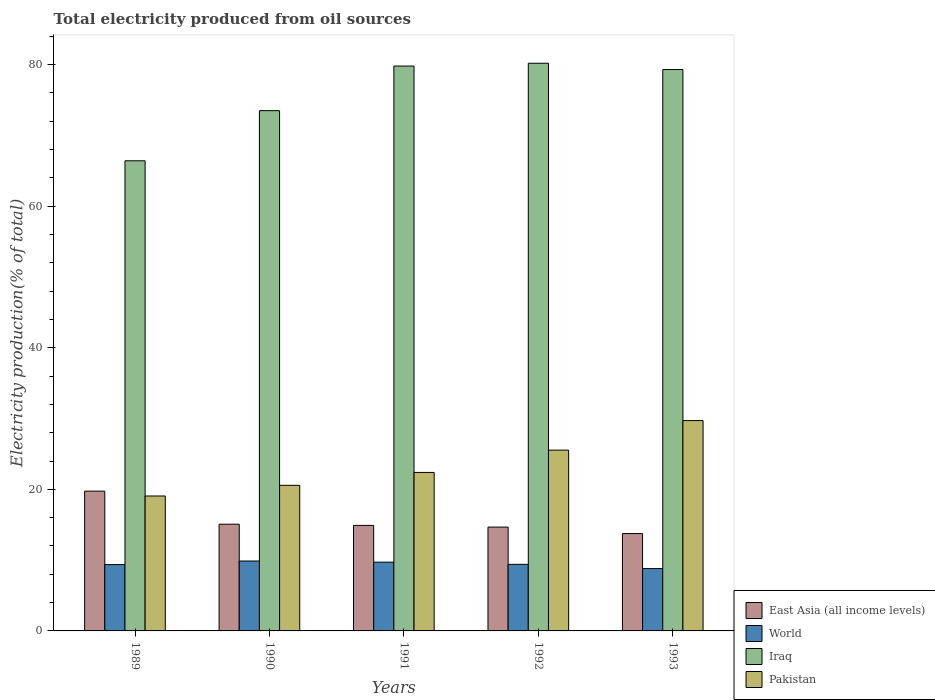Are the number of bars on each tick of the X-axis equal?
Provide a short and direct response. Yes. How many bars are there on the 3rd tick from the left?
Make the answer very short. 4. What is the label of the 5th group of bars from the left?
Provide a succinct answer. 1993. What is the total electricity produced in East Asia (all income levels) in 1992?
Provide a short and direct response. 14.67. Across all years, what is the maximum total electricity produced in Pakistan?
Ensure brevity in your answer.  29.71. Across all years, what is the minimum total electricity produced in Iraq?
Give a very brief answer. 66.41. What is the total total electricity produced in Iraq in the graph?
Make the answer very short. 379.17. What is the difference between the total electricity produced in World in 1990 and that in 1992?
Give a very brief answer. 0.47. What is the difference between the total electricity produced in East Asia (all income levels) in 1993 and the total electricity produced in World in 1990?
Your answer should be very brief. 3.88. What is the average total electricity produced in Iraq per year?
Your answer should be very brief. 75.83. In the year 1990, what is the difference between the total electricity produced in World and total electricity produced in Pakistan?
Make the answer very short. -10.69. In how many years, is the total electricity produced in Iraq greater than 60 %?
Your response must be concise. 5. What is the ratio of the total electricity produced in World in 1992 to that in 1993?
Ensure brevity in your answer.  1.07. Is the difference between the total electricity produced in World in 1989 and 1993 greater than the difference between the total electricity produced in Pakistan in 1989 and 1993?
Your answer should be very brief. Yes. What is the difference between the highest and the second highest total electricity produced in Iraq?
Keep it short and to the point. 0.4. What is the difference between the highest and the lowest total electricity produced in World?
Provide a succinct answer. 1.07. Is it the case that in every year, the sum of the total electricity produced in Pakistan and total electricity produced in World is greater than the sum of total electricity produced in East Asia (all income levels) and total electricity produced in Iraq?
Offer a terse response. No. What does the 4th bar from the right in 1991 represents?
Provide a short and direct response. East Asia (all income levels). Is it the case that in every year, the sum of the total electricity produced in Pakistan and total electricity produced in Iraq is greater than the total electricity produced in World?
Provide a succinct answer. Yes. How many years are there in the graph?
Your answer should be compact. 5. What is the difference between two consecutive major ticks on the Y-axis?
Offer a terse response. 20. Are the values on the major ticks of Y-axis written in scientific E-notation?
Make the answer very short. No. Does the graph contain grids?
Provide a succinct answer. No. Where does the legend appear in the graph?
Make the answer very short. Bottom right. How many legend labels are there?
Ensure brevity in your answer.  4. How are the legend labels stacked?
Your response must be concise. Vertical. What is the title of the graph?
Provide a short and direct response. Total electricity produced from oil sources. What is the label or title of the X-axis?
Offer a very short reply. Years. What is the label or title of the Y-axis?
Give a very brief answer. Electricity production(% of total). What is the Electricity production(% of total) in East Asia (all income levels) in 1989?
Give a very brief answer. 19.75. What is the Electricity production(% of total) in World in 1989?
Give a very brief answer. 9.37. What is the Electricity production(% of total) in Iraq in 1989?
Provide a short and direct response. 66.41. What is the Electricity production(% of total) of Pakistan in 1989?
Offer a very short reply. 19.06. What is the Electricity production(% of total) in East Asia (all income levels) in 1990?
Your answer should be very brief. 15.08. What is the Electricity production(% of total) of World in 1990?
Your answer should be very brief. 9.88. What is the Electricity production(% of total) in Iraq in 1990?
Your response must be concise. 73.49. What is the Electricity production(% of total) of Pakistan in 1990?
Offer a terse response. 20.57. What is the Electricity production(% of total) of East Asia (all income levels) in 1991?
Make the answer very short. 14.91. What is the Electricity production(% of total) of World in 1991?
Offer a very short reply. 9.72. What is the Electricity production(% of total) of Iraq in 1991?
Provide a short and direct response. 79.79. What is the Electricity production(% of total) in Pakistan in 1991?
Give a very brief answer. 22.39. What is the Electricity production(% of total) of East Asia (all income levels) in 1992?
Your answer should be compact. 14.67. What is the Electricity production(% of total) of World in 1992?
Your response must be concise. 9.4. What is the Electricity production(% of total) in Iraq in 1992?
Give a very brief answer. 80.19. What is the Electricity production(% of total) of Pakistan in 1992?
Provide a short and direct response. 25.54. What is the Electricity production(% of total) of East Asia (all income levels) in 1993?
Ensure brevity in your answer.  13.75. What is the Electricity production(% of total) of World in 1993?
Ensure brevity in your answer.  8.8. What is the Electricity production(% of total) in Iraq in 1993?
Offer a terse response. 79.3. What is the Electricity production(% of total) of Pakistan in 1993?
Offer a terse response. 29.71. Across all years, what is the maximum Electricity production(% of total) of East Asia (all income levels)?
Keep it short and to the point. 19.75. Across all years, what is the maximum Electricity production(% of total) in World?
Make the answer very short. 9.88. Across all years, what is the maximum Electricity production(% of total) of Iraq?
Keep it short and to the point. 80.19. Across all years, what is the maximum Electricity production(% of total) of Pakistan?
Provide a succinct answer. 29.71. Across all years, what is the minimum Electricity production(% of total) in East Asia (all income levels)?
Your answer should be very brief. 13.75. Across all years, what is the minimum Electricity production(% of total) in World?
Make the answer very short. 8.8. Across all years, what is the minimum Electricity production(% of total) in Iraq?
Offer a very short reply. 66.41. Across all years, what is the minimum Electricity production(% of total) in Pakistan?
Keep it short and to the point. 19.06. What is the total Electricity production(% of total) in East Asia (all income levels) in the graph?
Offer a very short reply. 78.15. What is the total Electricity production(% of total) in World in the graph?
Offer a very short reply. 47.17. What is the total Electricity production(% of total) in Iraq in the graph?
Keep it short and to the point. 379.17. What is the total Electricity production(% of total) in Pakistan in the graph?
Offer a terse response. 117.26. What is the difference between the Electricity production(% of total) in East Asia (all income levels) in 1989 and that in 1990?
Your answer should be compact. 4.67. What is the difference between the Electricity production(% of total) of World in 1989 and that in 1990?
Provide a short and direct response. -0.51. What is the difference between the Electricity production(% of total) in Iraq in 1989 and that in 1990?
Ensure brevity in your answer.  -7.08. What is the difference between the Electricity production(% of total) in Pakistan in 1989 and that in 1990?
Offer a very short reply. -1.51. What is the difference between the Electricity production(% of total) in East Asia (all income levels) in 1989 and that in 1991?
Offer a very short reply. 4.84. What is the difference between the Electricity production(% of total) in World in 1989 and that in 1991?
Keep it short and to the point. -0.35. What is the difference between the Electricity production(% of total) in Iraq in 1989 and that in 1991?
Offer a very short reply. -13.38. What is the difference between the Electricity production(% of total) of Pakistan in 1989 and that in 1991?
Provide a short and direct response. -3.33. What is the difference between the Electricity production(% of total) in East Asia (all income levels) in 1989 and that in 1992?
Keep it short and to the point. 5.08. What is the difference between the Electricity production(% of total) in World in 1989 and that in 1992?
Your answer should be compact. -0.04. What is the difference between the Electricity production(% of total) of Iraq in 1989 and that in 1992?
Provide a short and direct response. -13.78. What is the difference between the Electricity production(% of total) in Pakistan in 1989 and that in 1992?
Make the answer very short. -6.48. What is the difference between the Electricity production(% of total) of East Asia (all income levels) in 1989 and that in 1993?
Ensure brevity in your answer.  5.99. What is the difference between the Electricity production(% of total) in World in 1989 and that in 1993?
Make the answer very short. 0.56. What is the difference between the Electricity production(% of total) of Iraq in 1989 and that in 1993?
Your response must be concise. -12.89. What is the difference between the Electricity production(% of total) of Pakistan in 1989 and that in 1993?
Your answer should be very brief. -10.65. What is the difference between the Electricity production(% of total) in East Asia (all income levels) in 1990 and that in 1991?
Your answer should be very brief. 0.17. What is the difference between the Electricity production(% of total) of World in 1990 and that in 1991?
Provide a succinct answer. 0.16. What is the difference between the Electricity production(% of total) in Iraq in 1990 and that in 1991?
Your answer should be very brief. -6.3. What is the difference between the Electricity production(% of total) in Pakistan in 1990 and that in 1991?
Provide a succinct answer. -1.82. What is the difference between the Electricity production(% of total) in East Asia (all income levels) in 1990 and that in 1992?
Offer a terse response. 0.41. What is the difference between the Electricity production(% of total) of World in 1990 and that in 1992?
Give a very brief answer. 0.47. What is the difference between the Electricity production(% of total) in Iraq in 1990 and that in 1992?
Make the answer very short. -6.69. What is the difference between the Electricity production(% of total) in Pakistan in 1990 and that in 1992?
Provide a short and direct response. -4.97. What is the difference between the Electricity production(% of total) in East Asia (all income levels) in 1990 and that in 1993?
Ensure brevity in your answer.  1.32. What is the difference between the Electricity production(% of total) in World in 1990 and that in 1993?
Ensure brevity in your answer.  1.07. What is the difference between the Electricity production(% of total) of Iraq in 1990 and that in 1993?
Your answer should be very brief. -5.8. What is the difference between the Electricity production(% of total) of Pakistan in 1990 and that in 1993?
Offer a very short reply. -9.14. What is the difference between the Electricity production(% of total) in East Asia (all income levels) in 1991 and that in 1992?
Offer a very short reply. 0.24. What is the difference between the Electricity production(% of total) in World in 1991 and that in 1992?
Make the answer very short. 0.31. What is the difference between the Electricity production(% of total) in Iraq in 1991 and that in 1992?
Keep it short and to the point. -0.4. What is the difference between the Electricity production(% of total) in Pakistan in 1991 and that in 1992?
Your response must be concise. -3.15. What is the difference between the Electricity production(% of total) in East Asia (all income levels) in 1991 and that in 1993?
Keep it short and to the point. 1.15. What is the difference between the Electricity production(% of total) in World in 1991 and that in 1993?
Offer a terse response. 0.91. What is the difference between the Electricity production(% of total) of Iraq in 1991 and that in 1993?
Make the answer very short. 0.49. What is the difference between the Electricity production(% of total) of Pakistan in 1991 and that in 1993?
Your response must be concise. -7.32. What is the difference between the Electricity production(% of total) in East Asia (all income levels) in 1992 and that in 1993?
Make the answer very short. 0.92. What is the difference between the Electricity production(% of total) of World in 1992 and that in 1993?
Offer a terse response. 0.6. What is the difference between the Electricity production(% of total) of Iraq in 1992 and that in 1993?
Your response must be concise. 0.89. What is the difference between the Electricity production(% of total) in Pakistan in 1992 and that in 1993?
Your response must be concise. -4.17. What is the difference between the Electricity production(% of total) in East Asia (all income levels) in 1989 and the Electricity production(% of total) in World in 1990?
Keep it short and to the point. 9.87. What is the difference between the Electricity production(% of total) of East Asia (all income levels) in 1989 and the Electricity production(% of total) of Iraq in 1990?
Make the answer very short. -53.75. What is the difference between the Electricity production(% of total) of East Asia (all income levels) in 1989 and the Electricity production(% of total) of Pakistan in 1990?
Make the answer very short. -0.82. What is the difference between the Electricity production(% of total) in World in 1989 and the Electricity production(% of total) in Iraq in 1990?
Ensure brevity in your answer.  -64.12. What is the difference between the Electricity production(% of total) in World in 1989 and the Electricity production(% of total) in Pakistan in 1990?
Keep it short and to the point. -11.2. What is the difference between the Electricity production(% of total) of Iraq in 1989 and the Electricity production(% of total) of Pakistan in 1990?
Keep it short and to the point. 45.84. What is the difference between the Electricity production(% of total) in East Asia (all income levels) in 1989 and the Electricity production(% of total) in World in 1991?
Your response must be concise. 10.03. What is the difference between the Electricity production(% of total) in East Asia (all income levels) in 1989 and the Electricity production(% of total) in Iraq in 1991?
Your answer should be very brief. -60.04. What is the difference between the Electricity production(% of total) of East Asia (all income levels) in 1989 and the Electricity production(% of total) of Pakistan in 1991?
Your response must be concise. -2.64. What is the difference between the Electricity production(% of total) in World in 1989 and the Electricity production(% of total) in Iraq in 1991?
Ensure brevity in your answer.  -70.42. What is the difference between the Electricity production(% of total) in World in 1989 and the Electricity production(% of total) in Pakistan in 1991?
Keep it short and to the point. -13.02. What is the difference between the Electricity production(% of total) in Iraq in 1989 and the Electricity production(% of total) in Pakistan in 1991?
Your answer should be compact. 44.02. What is the difference between the Electricity production(% of total) in East Asia (all income levels) in 1989 and the Electricity production(% of total) in World in 1992?
Your response must be concise. 10.34. What is the difference between the Electricity production(% of total) in East Asia (all income levels) in 1989 and the Electricity production(% of total) in Iraq in 1992?
Offer a terse response. -60.44. What is the difference between the Electricity production(% of total) of East Asia (all income levels) in 1989 and the Electricity production(% of total) of Pakistan in 1992?
Ensure brevity in your answer.  -5.79. What is the difference between the Electricity production(% of total) in World in 1989 and the Electricity production(% of total) in Iraq in 1992?
Your answer should be very brief. -70.82. What is the difference between the Electricity production(% of total) of World in 1989 and the Electricity production(% of total) of Pakistan in 1992?
Keep it short and to the point. -16.17. What is the difference between the Electricity production(% of total) in Iraq in 1989 and the Electricity production(% of total) in Pakistan in 1992?
Give a very brief answer. 40.87. What is the difference between the Electricity production(% of total) in East Asia (all income levels) in 1989 and the Electricity production(% of total) in World in 1993?
Keep it short and to the point. 10.94. What is the difference between the Electricity production(% of total) in East Asia (all income levels) in 1989 and the Electricity production(% of total) in Iraq in 1993?
Provide a succinct answer. -59.55. What is the difference between the Electricity production(% of total) in East Asia (all income levels) in 1989 and the Electricity production(% of total) in Pakistan in 1993?
Give a very brief answer. -9.96. What is the difference between the Electricity production(% of total) in World in 1989 and the Electricity production(% of total) in Iraq in 1993?
Your answer should be very brief. -69.93. What is the difference between the Electricity production(% of total) in World in 1989 and the Electricity production(% of total) in Pakistan in 1993?
Keep it short and to the point. -20.34. What is the difference between the Electricity production(% of total) of Iraq in 1989 and the Electricity production(% of total) of Pakistan in 1993?
Make the answer very short. 36.7. What is the difference between the Electricity production(% of total) of East Asia (all income levels) in 1990 and the Electricity production(% of total) of World in 1991?
Ensure brevity in your answer.  5.36. What is the difference between the Electricity production(% of total) of East Asia (all income levels) in 1990 and the Electricity production(% of total) of Iraq in 1991?
Give a very brief answer. -64.71. What is the difference between the Electricity production(% of total) in East Asia (all income levels) in 1990 and the Electricity production(% of total) in Pakistan in 1991?
Your response must be concise. -7.31. What is the difference between the Electricity production(% of total) of World in 1990 and the Electricity production(% of total) of Iraq in 1991?
Offer a terse response. -69.91. What is the difference between the Electricity production(% of total) of World in 1990 and the Electricity production(% of total) of Pakistan in 1991?
Your answer should be compact. -12.51. What is the difference between the Electricity production(% of total) of Iraq in 1990 and the Electricity production(% of total) of Pakistan in 1991?
Give a very brief answer. 51.1. What is the difference between the Electricity production(% of total) of East Asia (all income levels) in 1990 and the Electricity production(% of total) of World in 1992?
Provide a short and direct response. 5.67. What is the difference between the Electricity production(% of total) in East Asia (all income levels) in 1990 and the Electricity production(% of total) in Iraq in 1992?
Keep it short and to the point. -65.11. What is the difference between the Electricity production(% of total) in East Asia (all income levels) in 1990 and the Electricity production(% of total) in Pakistan in 1992?
Provide a succinct answer. -10.46. What is the difference between the Electricity production(% of total) in World in 1990 and the Electricity production(% of total) in Iraq in 1992?
Your answer should be very brief. -70.31. What is the difference between the Electricity production(% of total) of World in 1990 and the Electricity production(% of total) of Pakistan in 1992?
Give a very brief answer. -15.66. What is the difference between the Electricity production(% of total) of Iraq in 1990 and the Electricity production(% of total) of Pakistan in 1992?
Give a very brief answer. 47.95. What is the difference between the Electricity production(% of total) in East Asia (all income levels) in 1990 and the Electricity production(% of total) in World in 1993?
Your answer should be compact. 6.27. What is the difference between the Electricity production(% of total) of East Asia (all income levels) in 1990 and the Electricity production(% of total) of Iraq in 1993?
Keep it short and to the point. -64.22. What is the difference between the Electricity production(% of total) in East Asia (all income levels) in 1990 and the Electricity production(% of total) in Pakistan in 1993?
Make the answer very short. -14.63. What is the difference between the Electricity production(% of total) in World in 1990 and the Electricity production(% of total) in Iraq in 1993?
Make the answer very short. -69.42. What is the difference between the Electricity production(% of total) in World in 1990 and the Electricity production(% of total) in Pakistan in 1993?
Provide a succinct answer. -19.83. What is the difference between the Electricity production(% of total) of Iraq in 1990 and the Electricity production(% of total) of Pakistan in 1993?
Give a very brief answer. 43.78. What is the difference between the Electricity production(% of total) of East Asia (all income levels) in 1991 and the Electricity production(% of total) of World in 1992?
Give a very brief answer. 5.5. What is the difference between the Electricity production(% of total) of East Asia (all income levels) in 1991 and the Electricity production(% of total) of Iraq in 1992?
Provide a succinct answer. -65.28. What is the difference between the Electricity production(% of total) of East Asia (all income levels) in 1991 and the Electricity production(% of total) of Pakistan in 1992?
Make the answer very short. -10.63. What is the difference between the Electricity production(% of total) in World in 1991 and the Electricity production(% of total) in Iraq in 1992?
Give a very brief answer. -70.47. What is the difference between the Electricity production(% of total) of World in 1991 and the Electricity production(% of total) of Pakistan in 1992?
Give a very brief answer. -15.82. What is the difference between the Electricity production(% of total) of Iraq in 1991 and the Electricity production(% of total) of Pakistan in 1992?
Keep it short and to the point. 54.25. What is the difference between the Electricity production(% of total) in East Asia (all income levels) in 1991 and the Electricity production(% of total) in World in 1993?
Make the answer very short. 6.1. What is the difference between the Electricity production(% of total) of East Asia (all income levels) in 1991 and the Electricity production(% of total) of Iraq in 1993?
Give a very brief answer. -64.39. What is the difference between the Electricity production(% of total) in East Asia (all income levels) in 1991 and the Electricity production(% of total) in Pakistan in 1993?
Offer a terse response. -14.8. What is the difference between the Electricity production(% of total) in World in 1991 and the Electricity production(% of total) in Iraq in 1993?
Provide a succinct answer. -69.58. What is the difference between the Electricity production(% of total) of World in 1991 and the Electricity production(% of total) of Pakistan in 1993?
Your answer should be compact. -20. What is the difference between the Electricity production(% of total) in Iraq in 1991 and the Electricity production(% of total) in Pakistan in 1993?
Your response must be concise. 50.08. What is the difference between the Electricity production(% of total) in East Asia (all income levels) in 1992 and the Electricity production(% of total) in World in 1993?
Provide a succinct answer. 5.86. What is the difference between the Electricity production(% of total) of East Asia (all income levels) in 1992 and the Electricity production(% of total) of Iraq in 1993?
Offer a very short reply. -64.63. What is the difference between the Electricity production(% of total) in East Asia (all income levels) in 1992 and the Electricity production(% of total) in Pakistan in 1993?
Ensure brevity in your answer.  -15.04. What is the difference between the Electricity production(% of total) in World in 1992 and the Electricity production(% of total) in Iraq in 1993?
Your answer should be very brief. -69.89. What is the difference between the Electricity production(% of total) of World in 1992 and the Electricity production(% of total) of Pakistan in 1993?
Offer a very short reply. -20.31. What is the difference between the Electricity production(% of total) of Iraq in 1992 and the Electricity production(% of total) of Pakistan in 1993?
Give a very brief answer. 50.48. What is the average Electricity production(% of total) of East Asia (all income levels) per year?
Your answer should be compact. 15.63. What is the average Electricity production(% of total) of World per year?
Provide a succinct answer. 9.43. What is the average Electricity production(% of total) of Iraq per year?
Offer a terse response. 75.83. What is the average Electricity production(% of total) in Pakistan per year?
Make the answer very short. 23.45. In the year 1989, what is the difference between the Electricity production(% of total) in East Asia (all income levels) and Electricity production(% of total) in World?
Provide a short and direct response. 10.38. In the year 1989, what is the difference between the Electricity production(% of total) in East Asia (all income levels) and Electricity production(% of total) in Iraq?
Ensure brevity in your answer.  -46.66. In the year 1989, what is the difference between the Electricity production(% of total) in East Asia (all income levels) and Electricity production(% of total) in Pakistan?
Keep it short and to the point. 0.69. In the year 1989, what is the difference between the Electricity production(% of total) of World and Electricity production(% of total) of Iraq?
Provide a short and direct response. -57.04. In the year 1989, what is the difference between the Electricity production(% of total) in World and Electricity production(% of total) in Pakistan?
Provide a short and direct response. -9.69. In the year 1989, what is the difference between the Electricity production(% of total) in Iraq and Electricity production(% of total) in Pakistan?
Make the answer very short. 47.35. In the year 1990, what is the difference between the Electricity production(% of total) of East Asia (all income levels) and Electricity production(% of total) of World?
Your answer should be compact. 5.2. In the year 1990, what is the difference between the Electricity production(% of total) in East Asia (all income levels) and Electricity production(% of total) in Iraq?
Give a very brief answer. -58.42. In the year 1990, what is the difference between the Electricity production(% of total) in East Asia (all income levels) and Electricity production(% of total) in Pakistan?
Provide a short and direct response. -5.49. In the year 1990, what is the difference between the Electricity production(% of total) in World and Electricity production(% of total) in Iraq?
Offer a very short reply. -63.62. In the year 1990, what is the difference between the Electricity production(% of total) of World and Electricity production(% of total) of Pakistan?
Offer a very short reply. -10.69. In the year 1990, what is the difference between the Electricity production(% of total) in Iraq and Electricity production(% of total) in Pakistan?
Offer a terse response. 52.93. In the year 1991, what is the difference between the Electricity production(% of total) of East Asia (all income levels) and Electricity production(% of total) of World?
Make the answer very short. 5.19. In the year 1991, what is the difference between the Electricity production(% of total) in East Asia (all income levels) and Electricity production(% of total) in Iraq?
Your answer should be compact. -64.88. In the year 1991, what is the difference between the Electricity production(% of total) in East Asia (all income levels) and Electricity production(% of total) in Pakistan?
Keep it short and to the point. -7.48. In the year 1991, what is the difference between the Electricity production(% of total) of World and Electricity production(% of total) of Iraq?
Offer a very short reply. -70.07. In the year 1991, what is the difference between the Electricity production(% of total) of World and Electricity production(% of total) of Pakistan?
Offer a terse response. -12.67. In the year 1991, what is the difference between the Electricity production(% of total) in Iraq and Electricity production(% of total) in Pakistan?
Make the answer very short. 57.4. In the year 1992, what is the difference between the Electricity production(% of total) in East Asia (all income levels) and Electricity production(% of total) in World?
Your answer should be compact. 5.26. In the year 1992, what is the difference between the Electricity production(% of total) in East Asia (all income levels) and Electricity production(% of total) in Iraq?
Provide a succinct answer. -65.52. In the year 1992, what is the difference between the Electricity production(% of total) in East Asia (all income levels) and Electricity production(% of total) in Pakistan?
Provide a short and direct response. -10.87. In the year 1992, what is the difference between the Electricity production(% of total) in World and Electricity production(% of total) in Iraq?
Give a very brief answer. -70.78. In the year 1992, what is the difference between the Electricity production(% of total) in World and Electricity production(% of total) in Pakistan?
Your response must be concise. -16.13. In the year 1992, what is the difference between the Electricity production(% of total) in Iraq and Electricity production(% of total) in Pakistan?
Your response must be concise. 54.65. In the year 1993, what is the difference between the Electricity production(% of total) of East Asia (all income levels) and Electricity production(% of total) of World?
Provide a short and direct response. 4.95. In the year 1993, what is the difference between the Electricity production(% of total) of East Asia (all income levels) and Electricity production(% of total) of Iraq?
Your answer should be very brief. -65.54. In the year 1993, what is the difference between the Electricity production(% of total) in East Asia (all income levels) and Electricity production(% of total) in Pakistan?
Provide a short and direct response. -15.96. In the year 1993, what is the difference between the Electricity production(% of total) in World and Electricity production(% of total) in Iraq?
Provide a short and direct response. -70.49. In the year 1993, what is the difference between the Electricity production(% of total) in World and Electricity production(% of total) in Pakistan?
Provide a short and direct response. -20.91. In the year 1993, what is the difference between the Electricity production(% of total) of Iraq and Electricity production(% of total) of Pakistan?
Make the answer very short. 49.59. What is the ratio of the Electricity production(% of total) of East Asia (all income levels) in 1989 to that in 1990?
Ensure brevity in your answer.  1.31. What is the ratio of the Electricity production(% of total) in World in 1989 to that in 1990?
Give a very brief answer. 0.95. What is the ratio of the Electricity production(% of total) in Iraq in 1989 to that in 1990?
Ensure brevity in your answer.  0.9. What is the ratio of the Electricity production(% of total) in Pakistan in 1989 to that in 1990?
Offer a very short reply. 0.93. What is the ratio of the Electricity production(% of total) of East Asia (all income levels) in 1989 to that in 1991?
Ensure brevity in your answer.  1.32. What is the ratio of the Electricity production(% of total) in World in 1989 to that in 1991?
Make the answer very short. 0.96. What is the ratio of the Electricity production(% of total) of Iraq in 1989 to that in 1991?
Offer a very short reply. 0.83. What is the ratio of the Electricity production(% of total) in Pakistan in 1989 to that in 1991?
Offer a very short reply. 0.85. What is the ratio of the Electricity production(% of total) in East Asia (all income levels) in 1989 to that in 1992?
Provide a succinct answer. 1.35. What is the ratio of the Electricity production(% of total) in Iraq in 1989 to that in 1992?
Keep it short and to the point. 0.83. What is the ratio of the Electricity production(% of total) of Pakistan in 1989 to that in 1992?
Keep it short and to the point. 0.75. What is the ratio of the Electricity production(% of total) in East Asia (all income levels) in 1989 to that in 1993?
Keep it short and to the point. 1.44. What is the ratio of the Electricity production(% of total) in World in 1989 to that in 1993?
Make the answer very short. 1.06. What is the ratio of the Electricity production(% of total) in Iraq in 1989 to that in 1993?
Provide a short and direct response. 0.84. What is the ratio of the Electricity production(% of total) in Pakistan in 1989 to that in 1993?
Provide a succinct answer. 0.64. What is the ratio of the Electricity production(% of total) of East Asia (all income levels) in 1990 to that in 1991?
Ensure brevity in your answer.  1.01. What is the ratio of the Electricity production(% of total) of World in 1990 to that in 1991?
Your response must be concise. 1.02. What is the ratio of the Electricity production(% of total) in Iraq in 1990 to that in 1991?
Your response must be concise. 0.92. What is the ratio of the Electricity production(% of total) of Pakistan in 1990 to that in 1991?
Your response must be concise. 0.92. What is the ratio of the Electricity production(% of total) in East Asia (all income levels) in 1990 to that in 1992?
Make the answer very short. 1.03. What is the ratio of the Electricity production(% of total) of World in 1990 to that in 1992?
Provide a succinct answer. 1.05. What is the ratio of the Electricity production(% of total) in Iraq in 1990 to that in 1992?
Provide a succinct answer. 0.92. What is the ratio of the Electricity production(% of total) of Pakistan in 1990 to that in 1992?
Your response must be concise. 0.81. What is the ratio of the Electricity production(% of total) of East Asia (all income levels) in 1990 to that in 1993?
Provide a short and direct response. 1.1. What is the ratio of the Electricity production(% of total) of World in 1990 to that in 1993?
Provide a short and direct response. 1.12. What is the ratio of the Electricity production(% of total) of Iraq in 1990 to that in 1993?
Provide a succinct answer. 0.93. What is the ratio of the Electricity production(% of total) of Pakistan in 1990 to that in 1993?
Your answer should be very brief. 0.69. What is the ratio of the Electricity production(% of total) of East Asia (all income levels) in 1991 to that in 1992?
Your response must be concise. 1.02. What is the ratio of the Electricity production(% of total) in World in 1991 to that in 1992?
Provide a short and direct response. 1.03. What is the ratio of the Electricity production(% of total) in Iraq in 1991 to that in 1992?
Ensure brevity in your answer.  0.99. What is the ratio of the Electricity production(% of total) of Pakistan in 1991 to that in 1992?
Your response must be concise. 0.88. What is the ratio of the Electricity production(% of total) of East Asia (all income levels) in 1991 to that in 1993?
Your answer should be compact. 1.08. What is the ratio of the Electricity production(% of total) of World in 1991 to that in 1993?
Provide a short and direct response. 1.1. What is the ratio of the Electricity production(% of total) in Iraq in 1991 to that in 1993?
Provide a short and direct response. 1.01. What is the ratio of the Electricity production(% of total) of Pakistan in 1991 to that in 1993?
Ensure brevity in your answer.  0.75. What is the ratio of the Electricity production(% of total) in East Asia (all income levels) in 1992 to that in 1993?
Your answer should be very brief. 1.07. What is the ratio of the Electricity production(% of total) of World in 1992 to that in 1993?
Provide a short and direct response. 1.07. What is the ratio of the Electricity production(% of total) of Iraq in 1992 to that in 1993?
Provide a succinct answer. 1.01. What is the ratio of the Electricity production(% of total) in Pakistan in 1992 to that in 1993?
Provide a short and direct response. 0.86. What is the difference between the highest and the second highest Electricity production(% of total) in East Asia (all income levels)?
Your answer should be compact. 4.67. What is the difference between the highest and the second highest Electricity production(% of total) of World?
Your answer should be very brief. 0.16. What is the difference between the highest and the second highest Electricity production(% of total) in Iraq?
Make the answer very short. 0.4. What is the difference between the highest and the second highest Electricity production(% of total) in Pakistan?
Your response must be concise. 4.17. What is the difference between the highest and the lowest Electricity production(% of total) of East Asia (all income levels)?
Keep it short and to the point. 5.99. What is the difference between the highest and the lowest Electricity production(% of total) of World?
Provide a short and direct response. 1.07. What is the difference between the highest and the lowest Electricity production(% of total) of Iraq?
Give a very brief answer. 13.78. What is the difference between the highest and the lowest Electricity production(% of total) in Pakistan?
Offer a terse response. 10.65. 